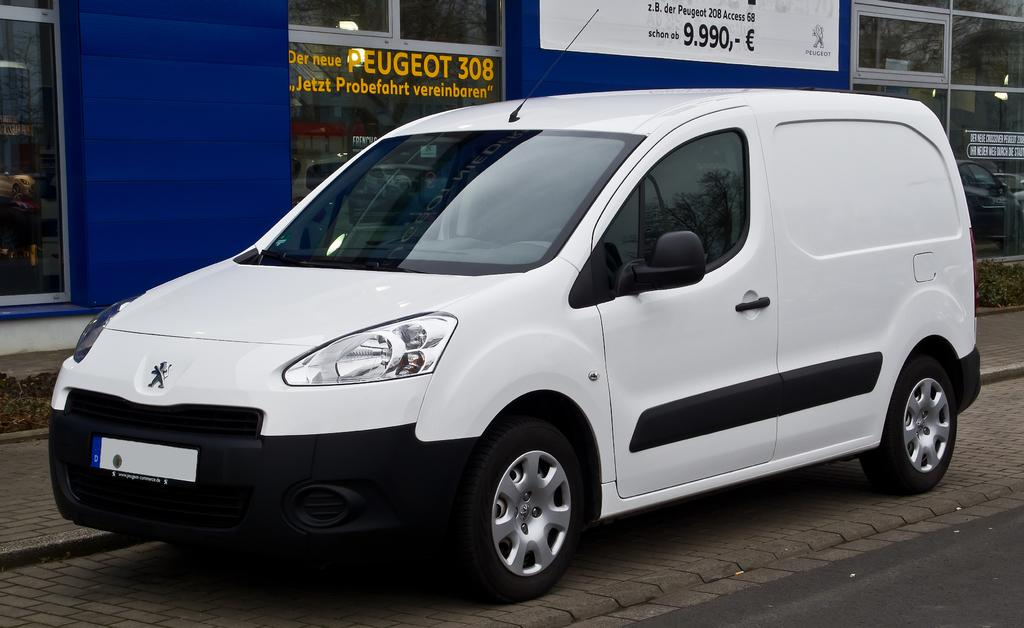<image>
Relay a brief, clear account of the picture shown. A white and black van parked in front of a building with Peugeot 308 written on it. 